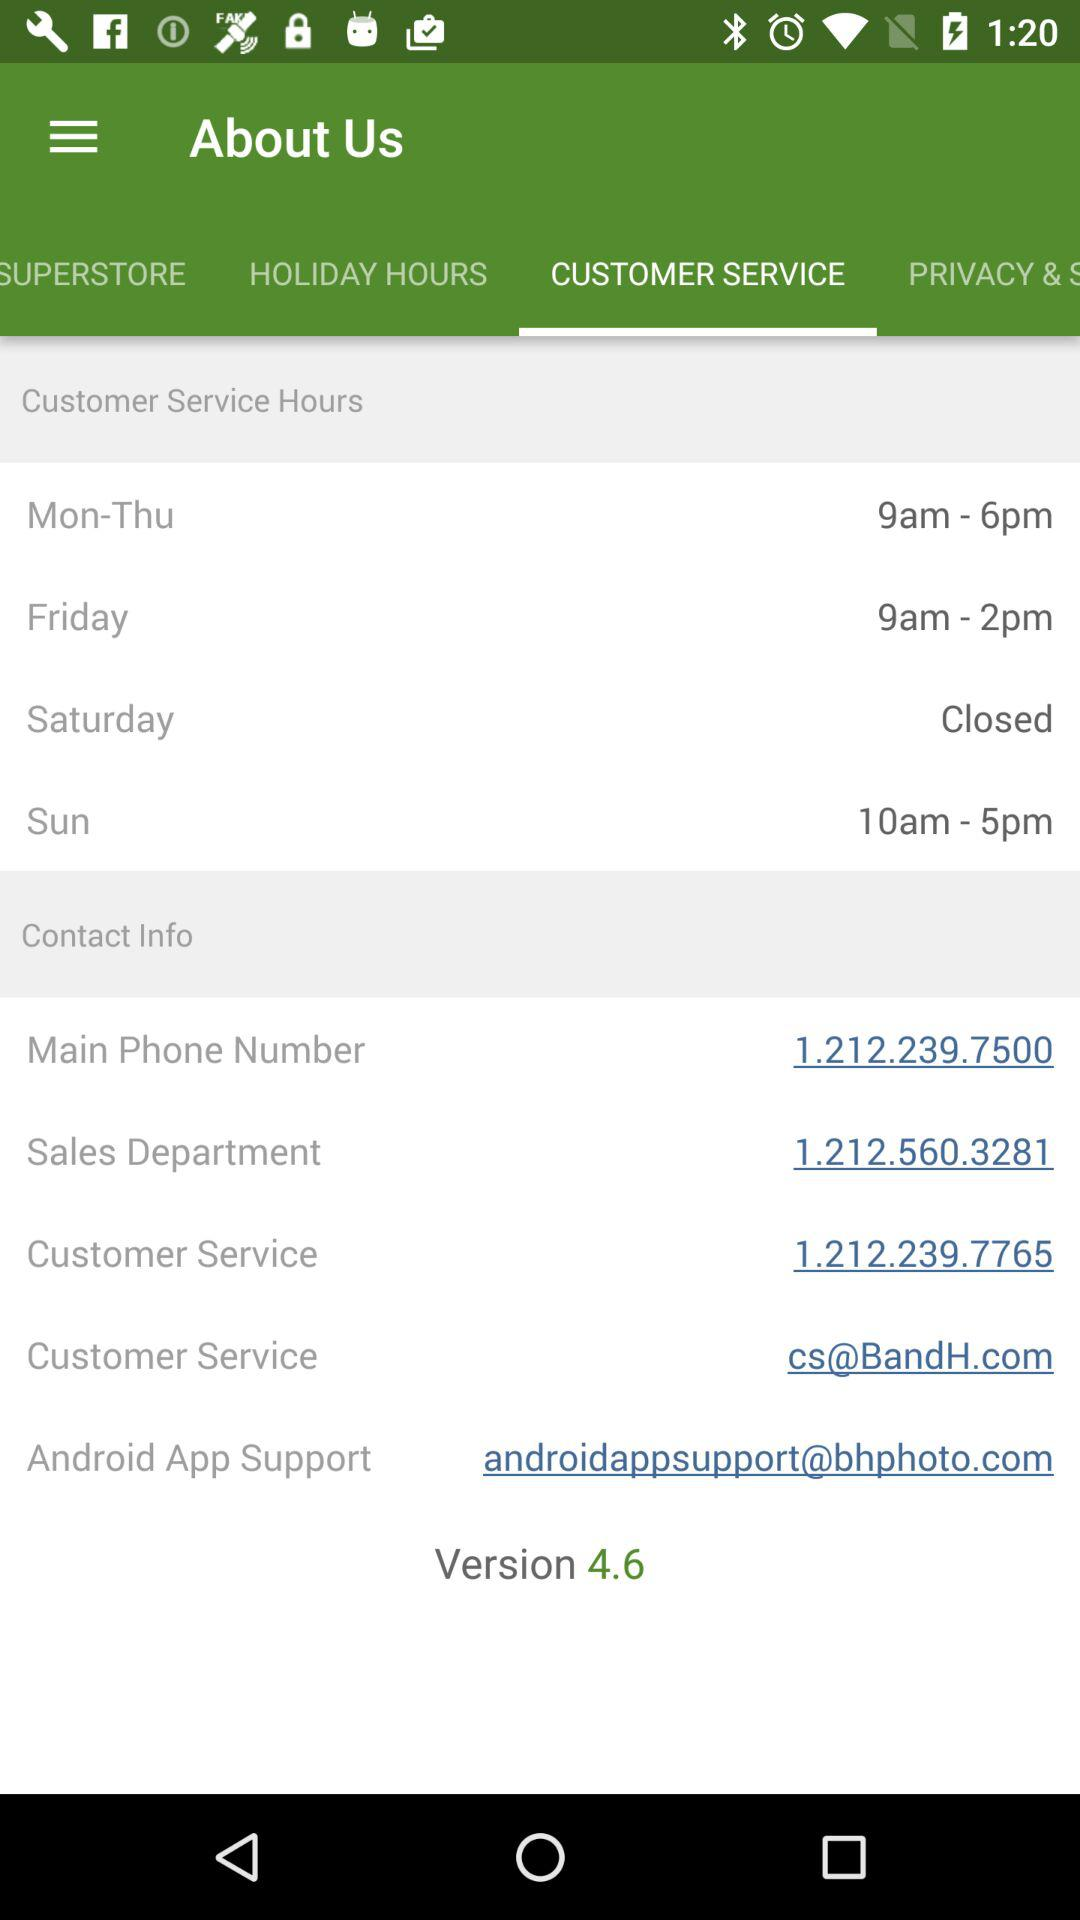Which tab am I using? You are using "CUSTOMER SERVICE" tab. 